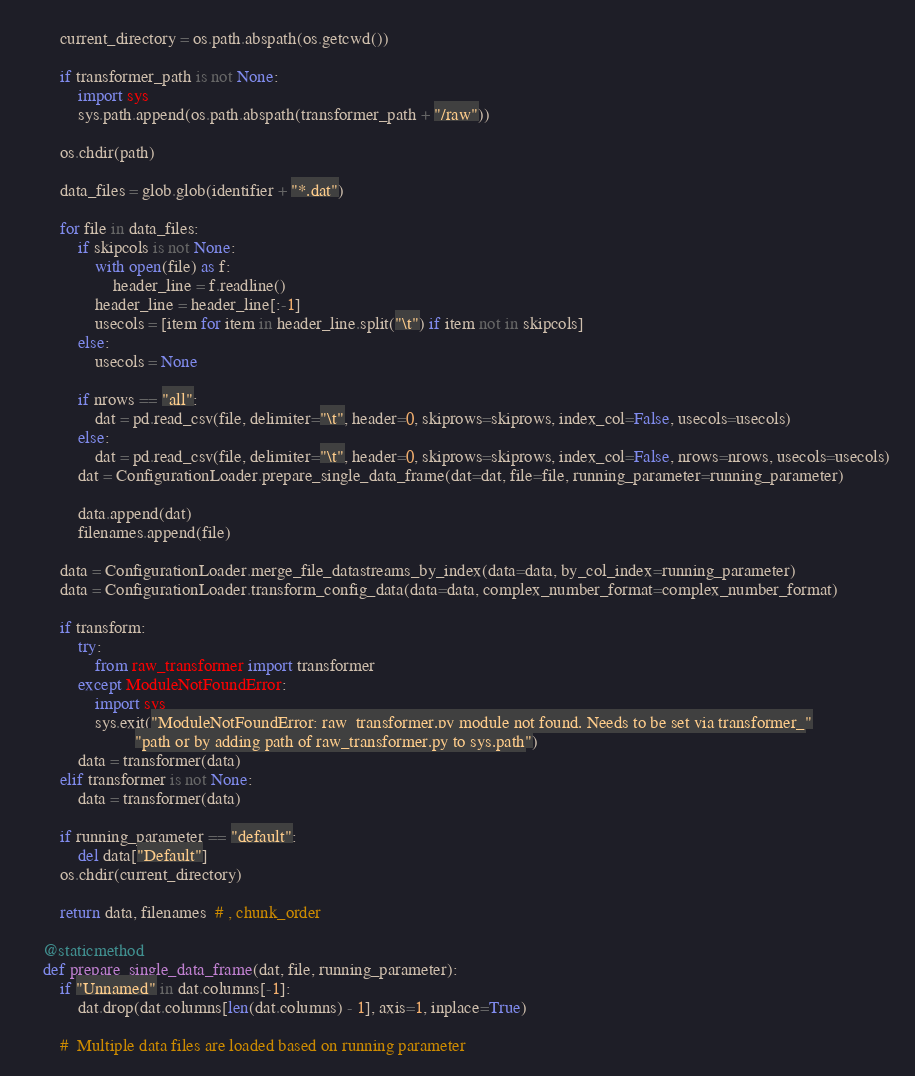Convert code to text. <code><loc_0><loc_0><loc_500><loc_500><_Python_>
        current_directory = os.path.abspath(os.getcwd())

        if transformer_path is not None:
            import sys
            sys.path.append(os.path.abspath(transformer_path + "/raw"))

        os.chdir(path)

        data_files = glob.glob(identifier + "*.dat")

        for file in data_files:
            if skipcols is not None:
                with open(file) as f:
                    header_line = f.readline()
                header_line = header_line[:-1]
                usecols = [item for item in header_line.split("\t") if item not in skipcols]
            else:
                usecols = None

            if nrows == "all":
                dat = pd.read_csv(file, delimiter="\t", header=0, skiprows=skiprows, index_col=False, usecols=usecols)
            else:
                dat = pd.read_csv(file, delimiter="\t", header=0, skiprows=skiprows, index_col=False, nrows=nrows, usecols=usecols)
            dat = ConfigurationLoader.prepare_single_data_frame(dat=dat, file=file, running_parameter=running_parameter)

            data.append(dat)
            filenames.append(file)

        data = ConfigurationLoader.merge_file_datastreams_by_index(data=data, by_col_index=running_parameter)
        data = ConfigurationLoader.transform_config_data(data=data, complex_number_format=complex_number_format)

        if transform:
            try:
                from raw_transformer import transformer
            except ModuleNotFoundError:
                import sys
                sys.exit("ModuleNotFoundError: raw_transformer.py module not found. Needs to be set via transformer_"
                         "path or by adding path of raw_transformer.py to sys.path")
            data = transformer(data)
        elif transformer is not None:
            data = transformer(data)

        if running_parameter == "default":
            del data["Default"]
        os.chdir(current_directory)

        return data, filenames  # , chunk_order

    @staticmethod
    def prepare_single_data_frame(dat, file, running_parameter):
        if "Unnamed" in dat.columns[-1]:
            dat.drop(dat.columns[len(dat.columns) - 1], axis=1, inplace=True)

        #  Multiple data files are loaded based on running parameter</code> 